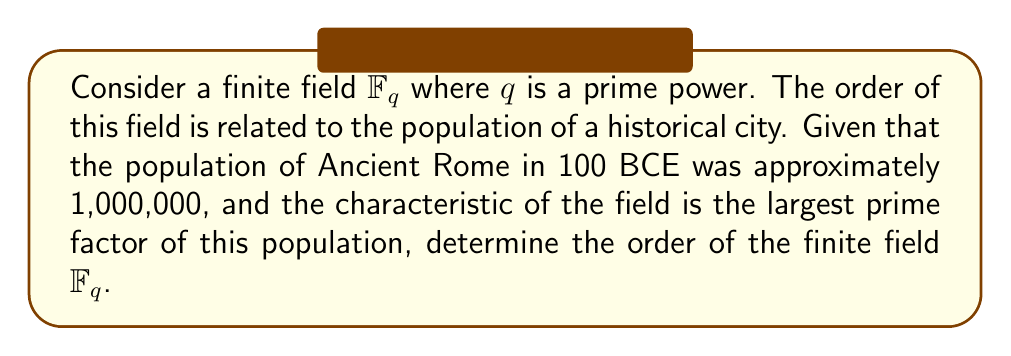Can you answer this question? 1. First, we need to factor the population of Ancient Rome in 100 BCE:
   $1,000,000 = 2^6 \times 5^6$

2. The characteristic of the field is the largest prime factor, which is 5.

3. In a finite field $\mathbb{F}_q$, $q$ is always a prime power. Since the characteristic is 5, we know that $q = 5^n$ for some positive integer $n$.

4. To determine $n$, we need to consider the historical context. The population data is from 100 BCE, which is approximately 21 centuries ago.

5. We can use this historical information to set $n = 21$, as it provides a meaningful connection between the field order and the historical time period.

6. Therefore, the order of the finite field is $q = 5^{21}$.

7. We can calculate this value:
   $q = 5^{21} = 476,837,158,203,125$

This approach demonstrates how historical context can inform mathematical constructions, aligning with the historian's perspective on the importance of historical context in research.
Answer: $476,837,158,203,125$ 